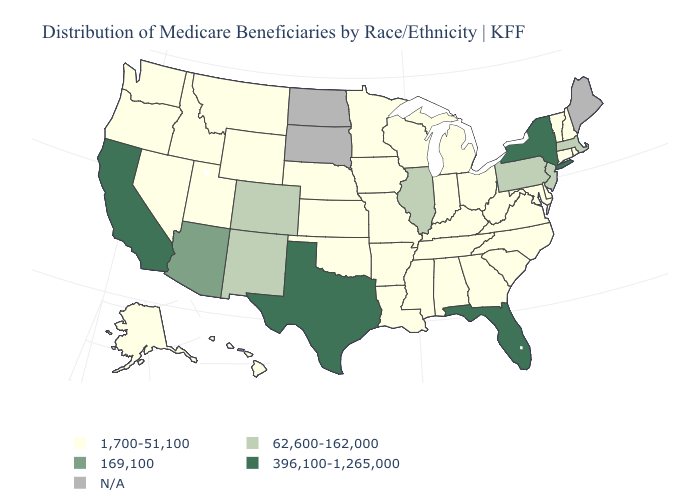Name the states that have a value in the range 1,700-51,100?
Give a very brief answer. Alabama, Alaska, Arkansas, Connecticut, Delaware, Georgia, Hawaii, Idaho, Indiana, Iowa, Kansas, Kentucky, Louisiana, Maryland, Michigan, Minnesota, Mississippi, Missouri, Montana, Nebraska, Nevada, New Hampshire, North Carolina, Ohio, Oklahoma, Oregon, Rhode Island, South Carolina, Tennessee, Utah, Vermont, Virginia, Washington, West Virginia, Wisconsin, Wyoming. Name the states that have a value in the range 396,100-1,265,000?
Concise answer only. California, Florida, New York, Texas. Name the states that have a value in the range 62,600-162,000?
Be succinct. Colorado, Illinois, Massachusetts, New Jersey, New Mexico, Pennsylvania. Does California have the highest value in the USA?
Short answer required. Yes. What is the value of Wyoming?
Be succinct. 1,700-51,100. Name the states that have a value in the range 169,100?
Keep it brief. Arizona. Does New Jersey have the lowest value in the USA?
Give a very brief answer. No. What is the lowest value in states that border Utah?
Short answer required. 1,700-51,100. What is the highest value in the USA?
Short answer required. 396,100-1,265,000. Name the states that have a value in the range 396,100-1,265,000?
Quick response, please. California, Florida, New York, Texas. Which states have the lowest value in the USA?
Keep it brief. Alabama, Alaska, Arkansas, Connecticut, Delaware, Georgia, Hawaii, Idaho, Indiana, Iowa, Kansas, Kentucky, Louisiana, Maryland, Michigan, Minnesota, Mississippi, Missouri, Montana, Nebraska, Nevada, New Hampshire, North Carolina, Ohio, Oklahoma, Oregon, Rhode Island, South Carolina, Tennessee, Utah, Vermont, Virginia, Washington, West Virginia, Wisconsin, Wyoming. Among the states that border Georgia , does South Carolina have the highest value?
Concise answer only. No. Name the states that have a value in the range 396,100-1,265,000?
Be succinct. California, Florida, New York, Texas. Name the states that have a value in the range N/A?
Keep it brief. Maine, North Dakota, South Dakota. 